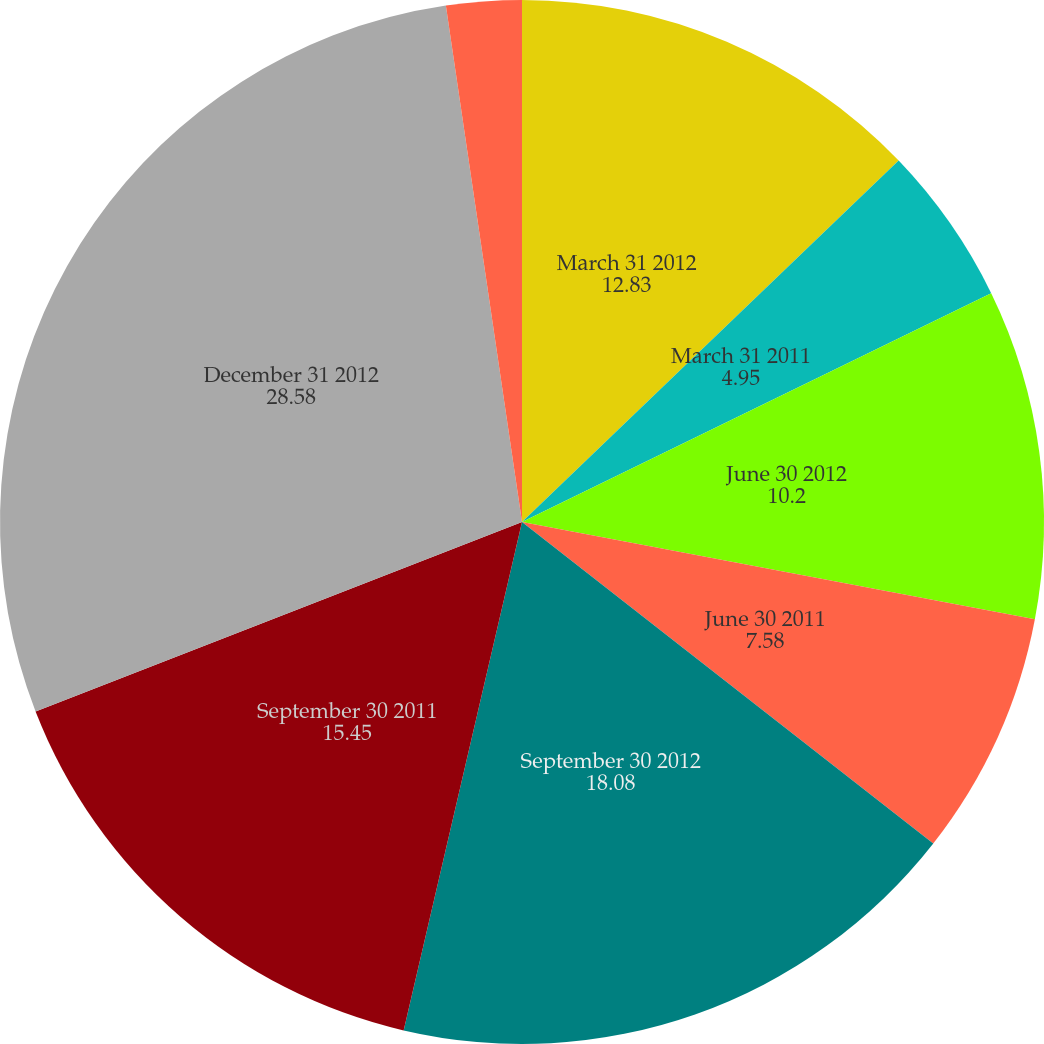Convert chart to OTSL. <chart><loc_0><loc_0><loc_500><loc_500><pie_chart><fcel>March 31 2012<fcel>March 31 2011<fcel>June 30 2012<fcel>June 30 2011<fcel>September 30 2012<fcel>September 30 2011<fcel>December 31 2012<fcel>December 31 2011<nl><fcel>12.83%<fcel>4.95%<fcel>10.2%<fcel>7.58%<fcel>18.08%<fcel>15.45%<fcel>28.58%<fcel>2.33%<nl></chart> 